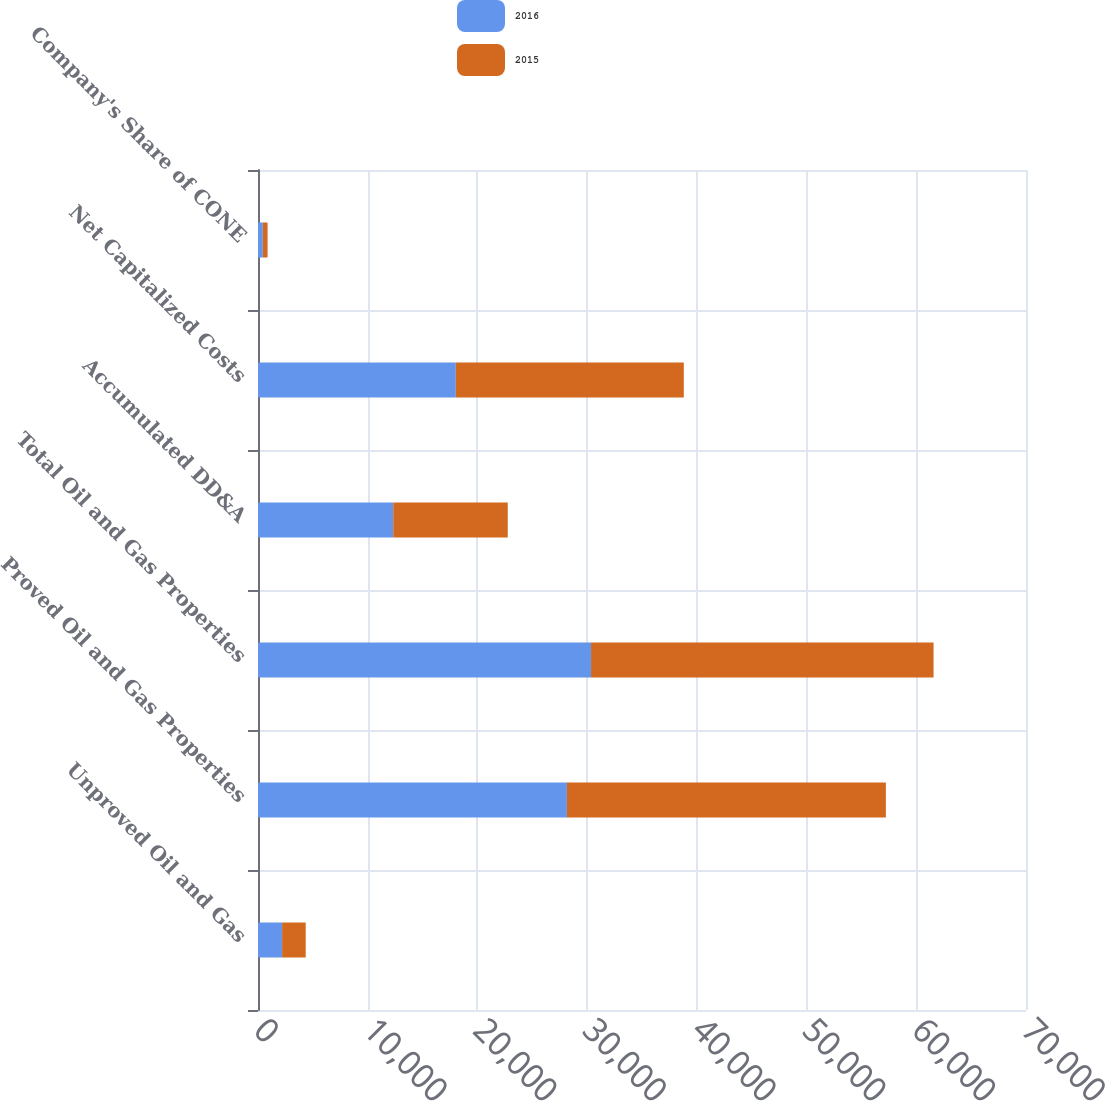Convert chart to OTSL. <chart><loc_0><loc_0><loc_500><loc_500><stacked_bar_chart><ecel><fcel>Unproved Oil and Gas<fcel>Proved Oil and Gas Properties<fcel>Total Oil and Gas Properties<fcel>Accumulated DD&A<fcel>Net Capitalized Costs<fcel>Company's Share of CONE<nl><fcel>2016<fcel>2197<fcel>28158<fcel>30355<fcel>12325<fcel>18030<fcel>440<nl><fcel>2015<fcel>2151<fcel>29069<fcel>31220<fcel>10439<fcel>20781<fcel>433<nl></chart> 